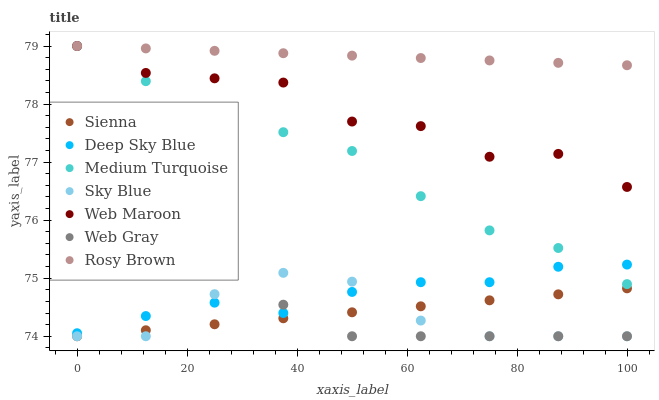Does Sky Blue have the minimum area under the curve?
Answer yes or no. Yes. Does Rosy Brown have the maximum area under the curve?
Answer yes or no. Yes. Does Deep Sky Blue have the minimum area under the curve?
Answer yes or no. No. Does Deep Sky Blue have the maximum area under the curve?
Answer yes or no. No. Is Sienna the smoothest?
Answer yes or no. Yes. Is Web Maroon the roughest?
Answer yes or no. Yes. Is Deep Sky Blue the smoothest?
Answer yes or no. No. Is Deep Sky Blue the roughest?
Answer yes or no. No. Does Web Gray have the lowest value?
Answer yes or no. Yes. Does Deep Sky Blue have the lowest value?
Answer yes or no. No. Does Medium Turquoise have the highest value?
Answer yes or no. Yes. Does Deep Sky Blue have the highest value?
Answer yes or no. No. Is Sky Blue less than Rosy Brown?
Answer yes or no. Yes. Is Medium Turquoise greater than Web Gray?
Answer yes or no. Yes. Does Medium Turquoise intersect Rosy Brown?
Answer yes or no. Yes. Is Medium Turquoise less than Rosy Brown?
Answer yes or no. No. Is Medium Turquoise greater than Rosy Brown?
Answer yes or no. No. Does Sky Blue intersect Rosy Brown?
Answer yes or no. No. 